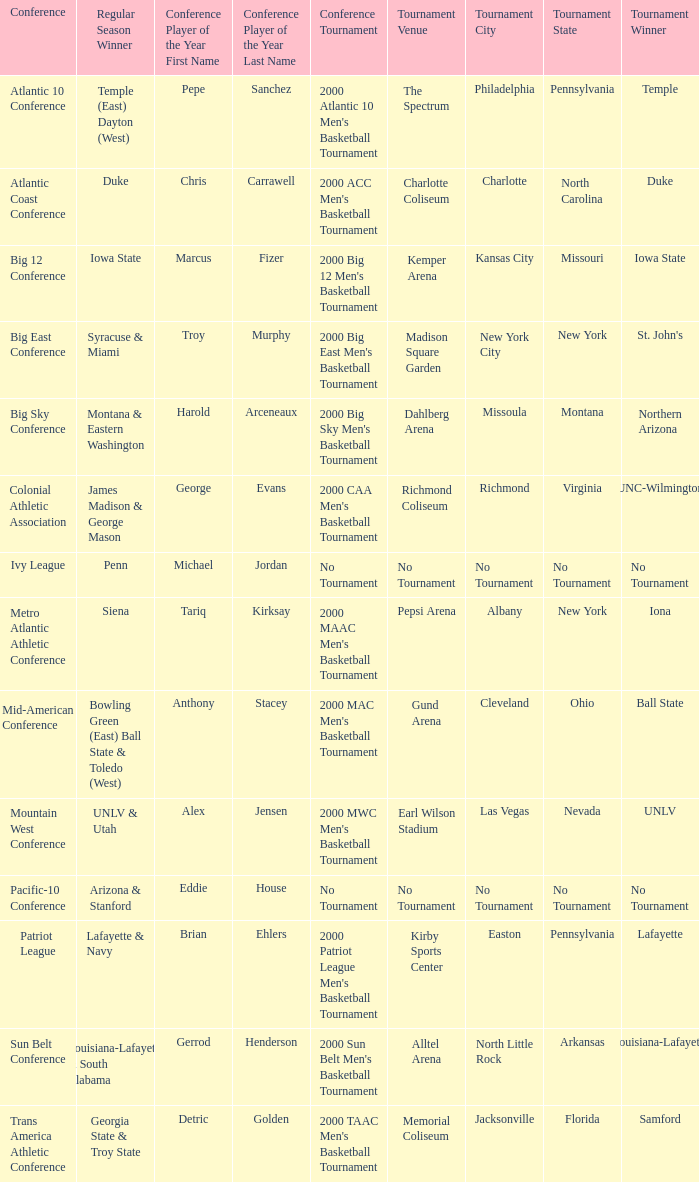Where was the Ivy League conference tournament? No Tournament. 